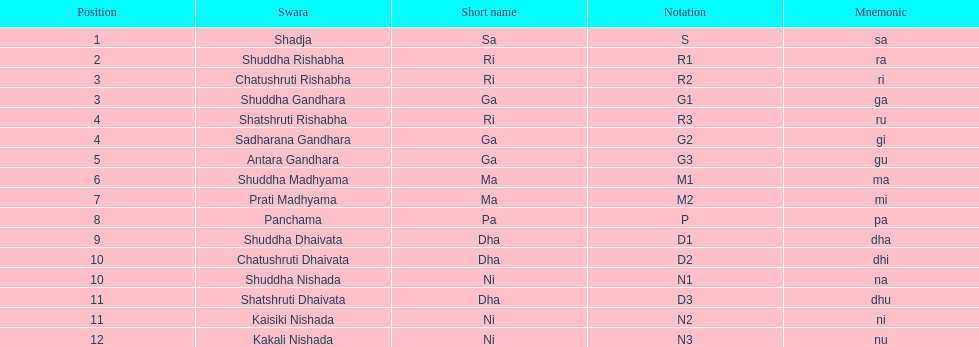Help me parse the entirety of this table. {'header': ['Position', 'Swara', 'Short name', 'Notation', 'Mnemonic'], 'rows': [['1', 'Shadja', 'Sa', 'S', 'sa'], ['2', 'Shuddha Rishabha', 'Ri', 'R1', 'ra'], ['3', 'Chatushruti Rishabha', 'Ri', 'R2', 'ri'], ['3', 'Shuddha Gandhara', 'Ga', 'G1', 'ga'], ['4', 'Shatshruti Rishabha', 'Ri', 'R3', 'ru'], ['4', 'Sadharana Gandhara', 'Ga', 'G2', 'gi'], ['5', 'Antara Gandhara', 'Ga', 'G3', 'gu'], ['6', 'Shuddha Madhyama', 'Ma', 'M1', 'ma'], ['7', 'Prati Madhyama', 'Ma', 'M2', 'mi'], ['8', 'Panchama', 'Pa', 'P', 'pa'], ['9', 'Shuddha Dhaivata', 'Dha', 'D1', 'dha'], ['10', 'Chatushruti Dhaivata', 'Dha', 'D2', 'dhi'], ['10', 'Shuddha Nishada', 'Ni', 'N1', 'na'], ['11', 'Shatshruti Dhaivata', 'Dha', 'D3', 'dhu'], ['11', 'Kaisiki Nishada', 'Ni', 'N2', 'ni'], ['12', 'Kakali Nishada', 'Ni', 'N3', 'nu']]} What is the total number of positions listed? 16. 